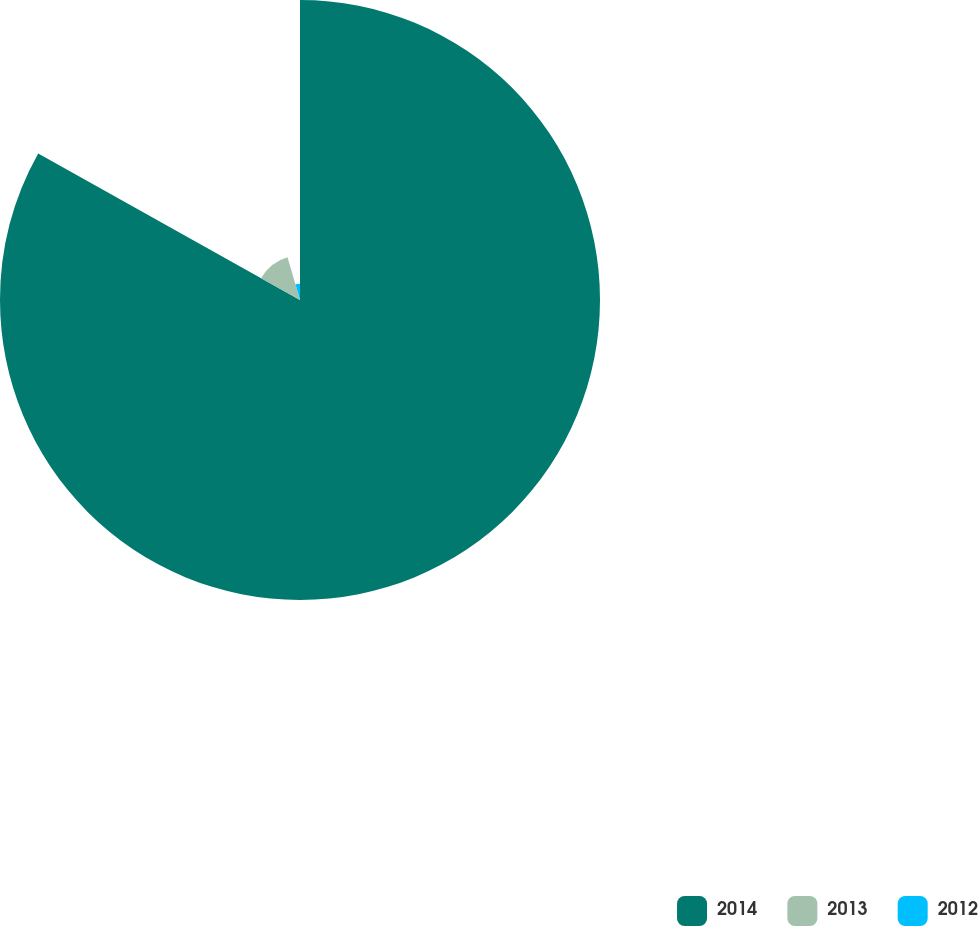Convert chart to OTSL. <chart><loc_0><loc_0><loc_500><loc_500><pie_chart><fcel>2014<fcel>2013<fcel>2012<nl><fcel>83.12%<fcel>12.37%<fcel>4.51%<nl></chart> 